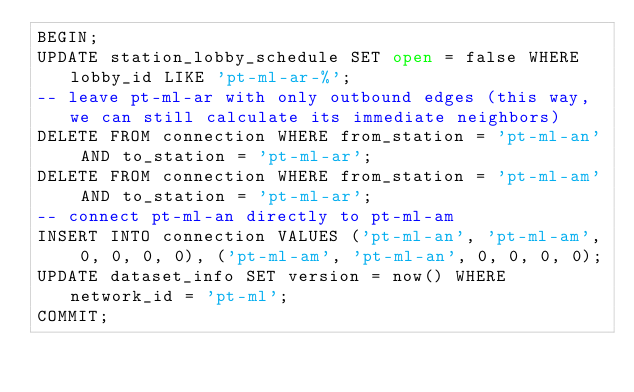<code> <loc_0><loc_0><loc_500><loc_500><_SQL_>BEGIN;
UPDATE station_lobby_schedule SET open = false WHERE lobby_id LIKE 'pt-ml-ar-%';
-- leave pt-ml-ar with only outbound edges (this way, we can still calculate its immediate neighbors)
DELETE FROM connection WHERE from_station = 'pt-ml-an' AND to_station = 'pt-ml-ar';
DELETE FROM connection WHERE from_station = 'pt-ml-am' AND to_station = 'pt-ml-ar';
-- connect pt-ml-an directly to pt-ml-am
INSERT INTO connection VALUES ('pt-ml-an', 'pt-ml-am', 0, 0, 0, 0), ('pt-ml-am', 'pt-ml-an', 0, 0, 0, 0);
UPDATE dataset_info SET version = now() WHERE network_id = 'pt-ml';
COMMIT;</code> 